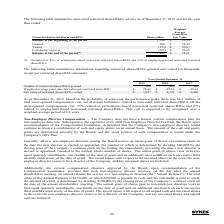According to Sykes Enterprises Incorporated's financial document, What is the Number of restricted shares/ RSUs granted in 2019? According to the financial document, 508 (in thousands). The relevant text states: "Granted 508 $ 28.43..." Also, What is the Fair value of restricted shares/RSUs vested  in 2018? According to the financial document, $8,342 (in thousands). The relevant text states: "value of restricted shares/RSUs vested $ 3,647 $ 8,342 $ 6,868..." Also, In which years is the Fair value of restricted shares/RSUs vested calculated? The document contains multiple relevant values: 2019, 2018, 2017. From the document: "2019 2018 2017 2019 2018 2017 2019 2018 2017..." Additionally, In which year was the Number of restricted shares/ RSUs granted the largest? According to the financial document, 2019. The relevant text states: "2019 2018 2017..." Also, can you calculate: What was the change in Number of restricted shares/ RSUs granted in 2019 from 2018? Based on the calculation: 508-492, the result is 16 (in thousands). This is based on the information: "Number of restricted shares/RSUs granted 508 492 480 Granted 508 $ 28.43..." The key data points involved are: 492, 508. Also, can you calculate: What was the percentage change in Number of restricted shares/ RSUs granted in 2019 from 2018? To answer this question, I need to perform calculations using the financial data. The calculation is: (508-492)/492, which equals 3.25 (percentage). This is based on the information: "Number of restricted shares/RSUs granted 508 492 480 Granted 508 $ 28.43..." The key data points involved are: 492, 508. 